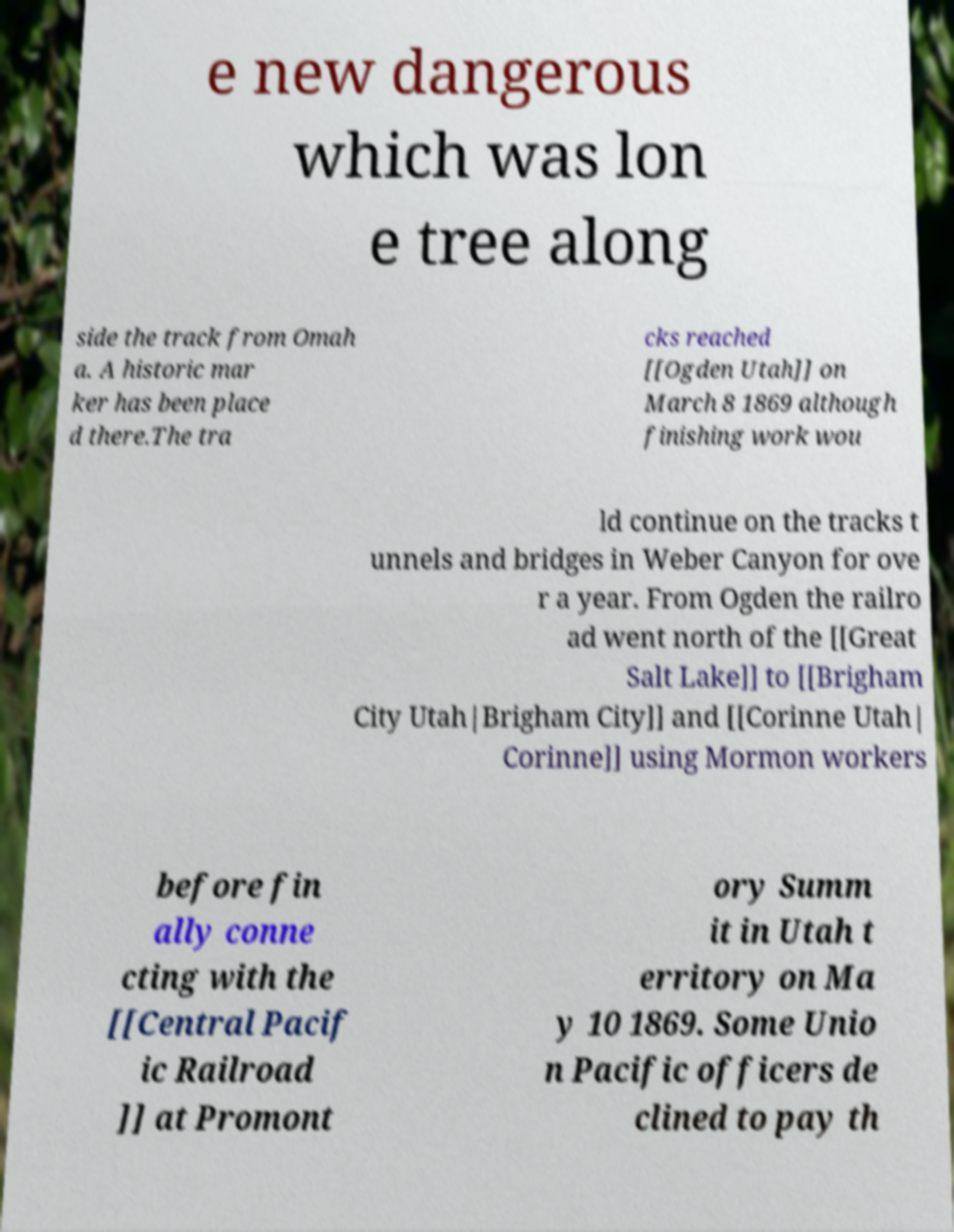What messages or text are displayed in this image? I need them in a readable, typed format. e new dangerous which was lon e tree along side the track from Omah a. A historic mar ker has been place d there.The tra cks reached [[Ogden Utah]] on March 8 1869 although finishing work wou ld continue on the tracks t unnels and bridges in Weber Canyon for ove r a year. From Ogden the railro ad went north of the [[Great Salt Lake]] to [[Brigham City Utah|Brigham City]] and [[Corinne Utah| Corinne]] using Mormon workers before fin ally conne cting with the [[Central Pacif ic Railroad ]] at Promont ory Summ it in Utah t erritory on Ma y 10 1869. Some Unio n Pacific officers de clined to pay th 